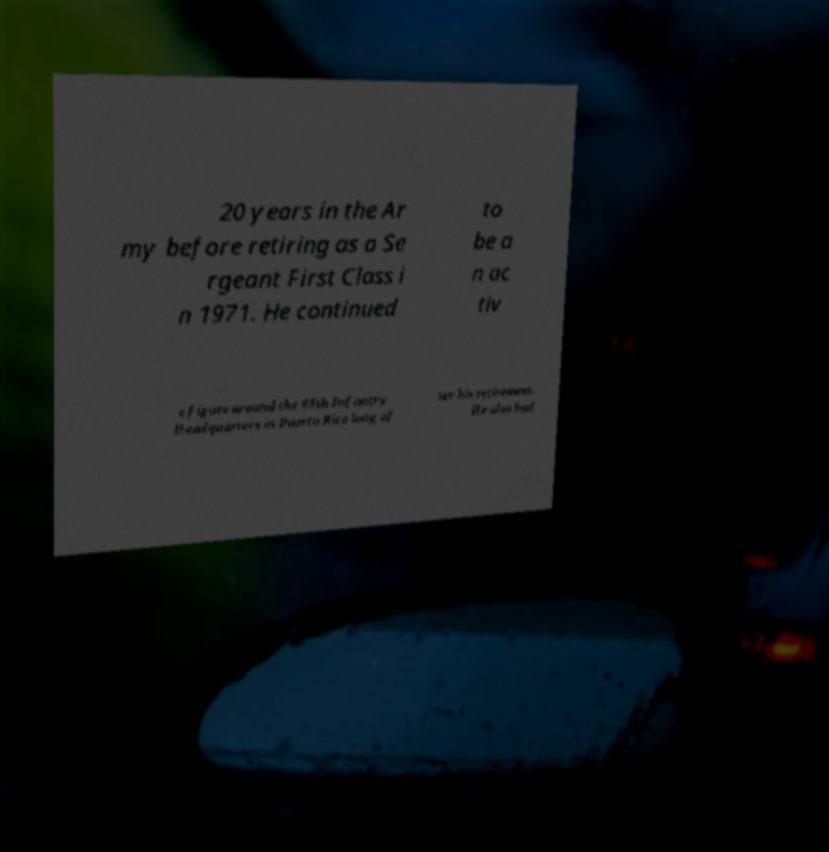Could you assist in decoding the text presented in this image and type it out clearly? 20 years in the Ar my before retiring as a Se rgeant First Class i n 1971. He continued to be a n ac tiv e figure around the 65th Infantry Headquarters in Puerto Rico long af ter his retirement. He also had 